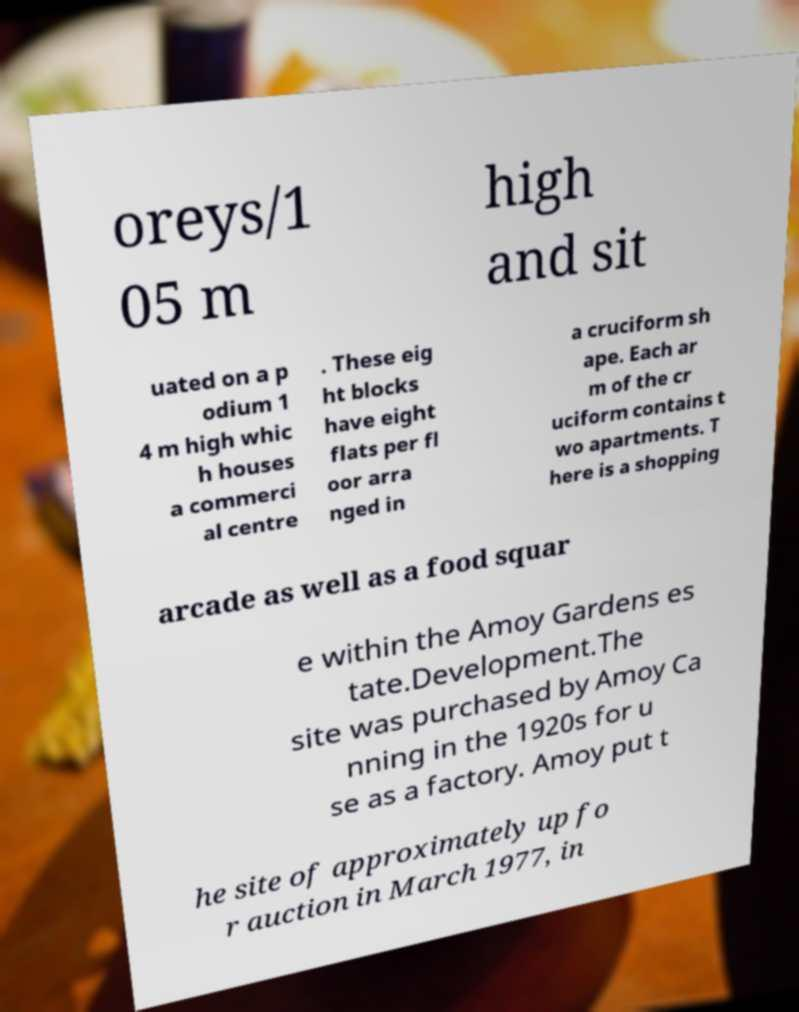Can you accurately transcribe the text from the provided image for me? oreys/1 05 m high and sit uated on a p odium 1 4 m high whic h houses a commerci al centre . These eig ht blocks have eight flats per fl oor arra nged in a cruciform sh ape. Each ar m of the cr uciform contains t wo apartments. T here is a shopping arcade as well as a food squar e within the Amoy Gardens es tate.Development.The site was purchased by Amoy Ca nning in the 1920s for u se as a factory. Amoy put t he site of approximately up fo r auction in March 1977, in 